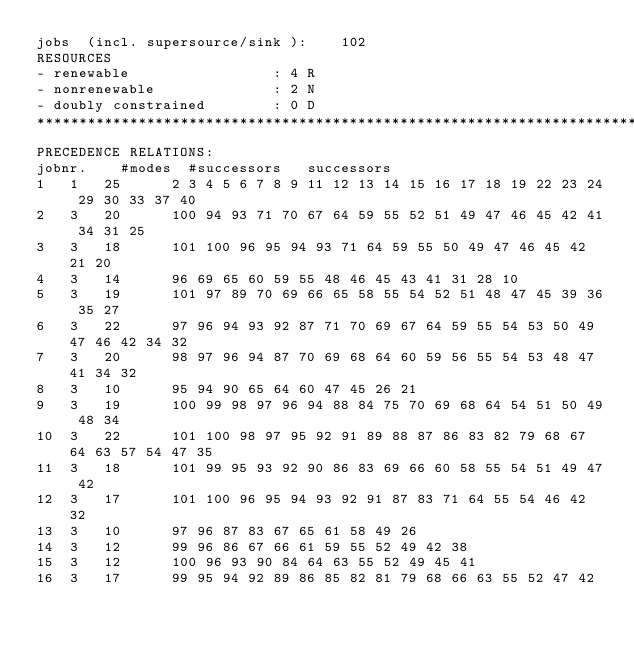Convert code to text. <code><loc_0><loc_0><loc_500><loc_500><_ObjectiveC_>jobs  (incl. supersource/sink ):	102
RESOURCES
- renewable                 : 4 R
- nonrenewable              : 2 N
- doubly constrained        : 0 D
************************************************************************
PRECEDENCE RELATIONS:
jobnr.    #modes  #successors   successors
1	1	25		2 3 4 5 6 7 8 9 11 12 13 14 15 16 17 18 19 22 23 24 29 30 33 37 40 
2	3	20		100 94 93 71 70 67 64 59 55 52 51 49 47 46 45 42 41 34 31 25 
3	3	18		101 100 96 95 94 93 71 64 59 55 50 49 47 46 45 42 21 20 
4	3	14		96 69 65 60 59 55 48 46 45 43 41 31 28 10 
5	3	19		101 97 89 70 69 66 65 58 55 54 52 51 48 47 45 39 36 35 27 
6	3	22		97 96 94 93 92 87 71 70 69 67 64 59 55 54 53 50 49 47 46 42 34 32 
7	3	20		98 97 96 94 87 70 69 68 64 60 59 56 55 54 53 48 47 41 34 32 
8	3	10		95 94 90 65 64 60 47 45 26 21 
9	3	19		100 99 98 97 96 94 88 84 75 70 69 68 64 54 51 50 49 48 34 
10	3	22		101 100 98 97 95 92 91 89 88 87 86 83 82 79 68 67 64 63 57 54 47 35 
11	3	18		101 99 95 93 92 90 86 83 69 66 60 58 55 54 51 49 47 42 
12	3	17		101 100 96 95 94 93 92 91 87 83 71 64 55 54 46 42 32 
13	3	10		97 96 87 83 67 65 61 58 49 26 
14	3	12		99 96 86 67 66 61 59 55 52 49 42 38 
15	3	12		100 96 93 90 84 64 63 55 52 49 45 41 
16	3	17		99 95 94 92 89 86 85 82 81 79 68 66 63 55 52 47 42 </code> 